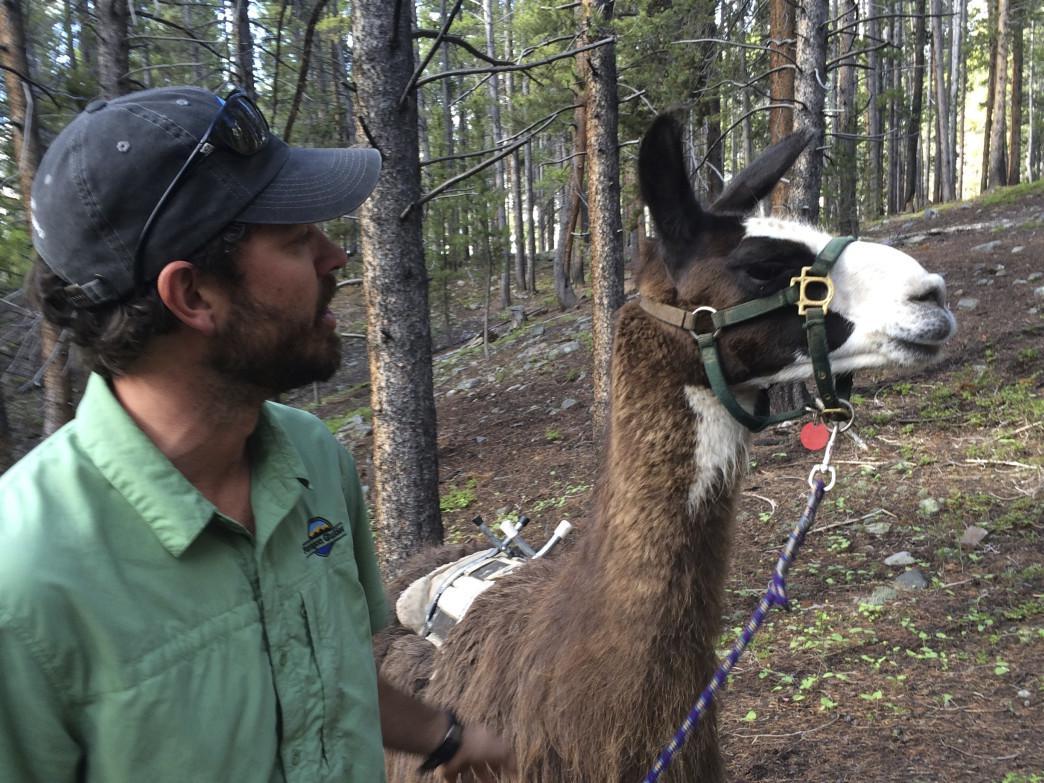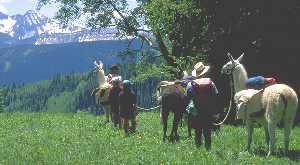The first image is the image on the left, the second image is the image on the right. Evaluate the accuracy of this statement regarding the images: "The llamas in the right image are carrying packs.". Is it true? Answer yes or no. Yes. The first image is the image on the left, the second image is the image on the right. Considering the images on both sides, is "The right image shows multiple people standing near multiple llamas wearing packs and facing mountain peaks." valid? Answer yes or no. Yes. 